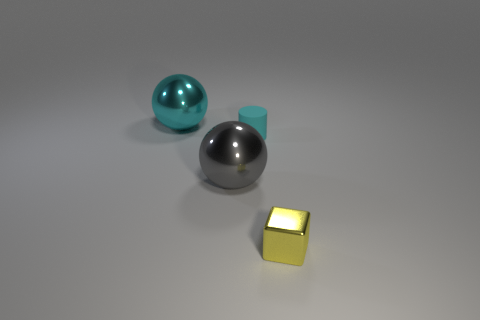How big is the gray ball?
Keep it short and to the point. Large. What size is the cyan thing behind the tiny cyan matte cylinder?
Offer a very short reply. Large. There is a thing that is both to the right of the large gray metallic sphere and on the left side of the small yellow thing; what shape is it?
Your answer should be very brief. Cylinder. How many other things are the same shape as the small metal object?
Offer a very short reply. 0. What is the color of the metal object that is the same size as the cyan sphere?
Provide a short and direct response. Gray. What number of objects are yellow matte cylinders or cyan objects?
Ensure brevity in your answer.  2. Are there any yellow metal objects in front of the small yellow block?
Keep it short and to the point. No. Is there a blue thing that has the same material as the small block?
Provide a short and direct response. No. There is another object that is the same color as the small rubber object; what size is it?
Keep it short and to the point. Large. What number of cylinders are either purple matte things or metal objects?
Your answer should be compact. 0. 